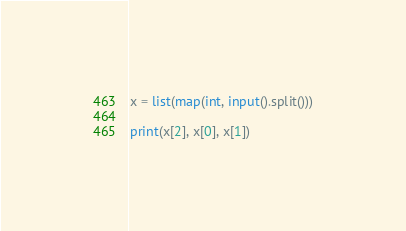Convert code to text. <code><loc_0><loc_0><loc_500><loc_500><_Python_>x = list(map(int, input().split()))

print(x[2], x[0], x[1])</code> 